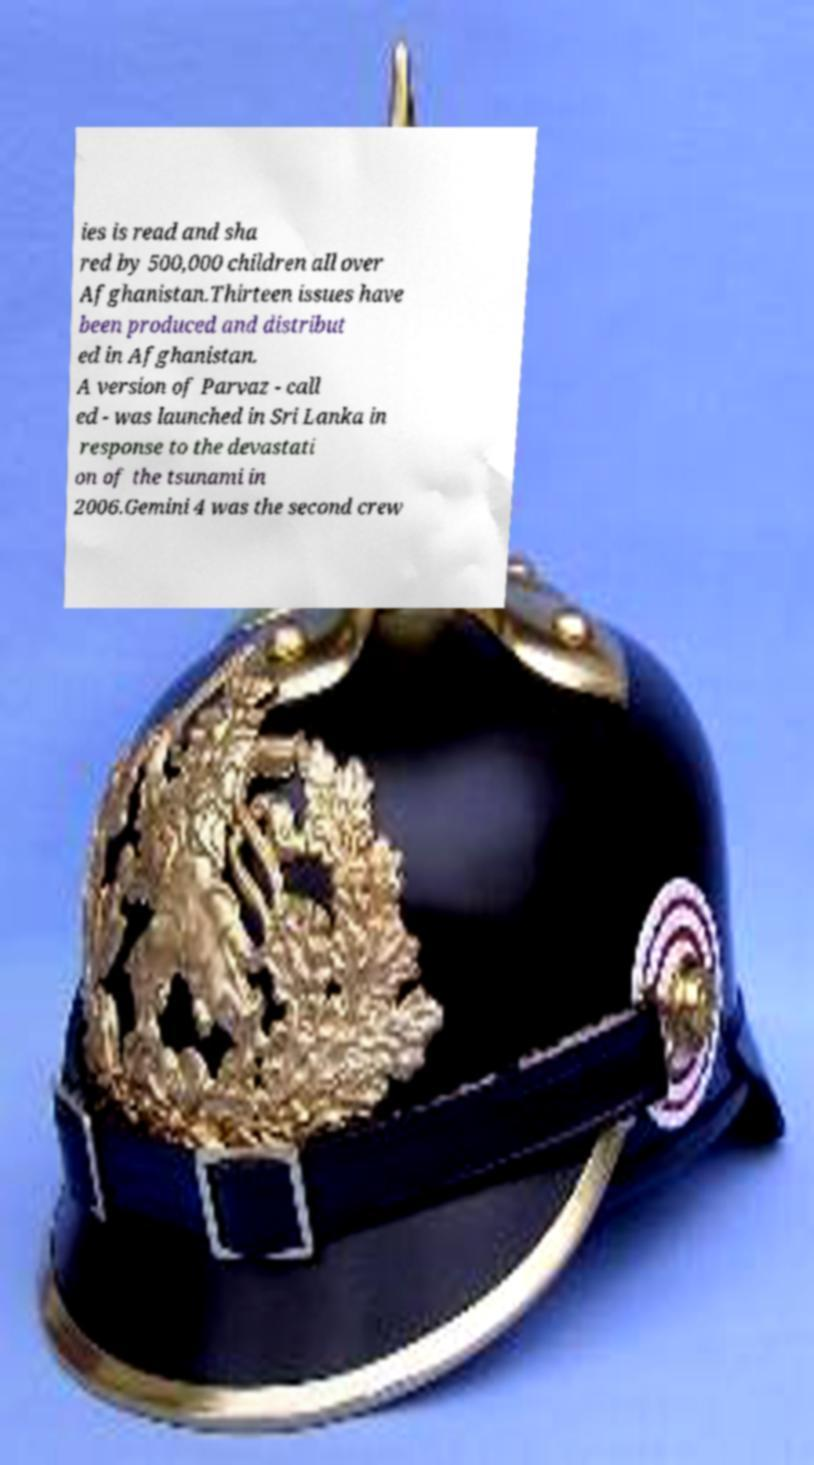Can you read and provide the text displayed in the image?This photo seems to have some interesting text. Can you extract and type it out for me? ies is read and sha red by 500,000 children all over Afghanistan.Thirteen issues have been produced and distribut ed in Afghanistan. A version of Parvaz - call ed - was launched in Sri Lanka in response to the devastati on of the tsunami in 2006.Gemini 4 was the second crew 